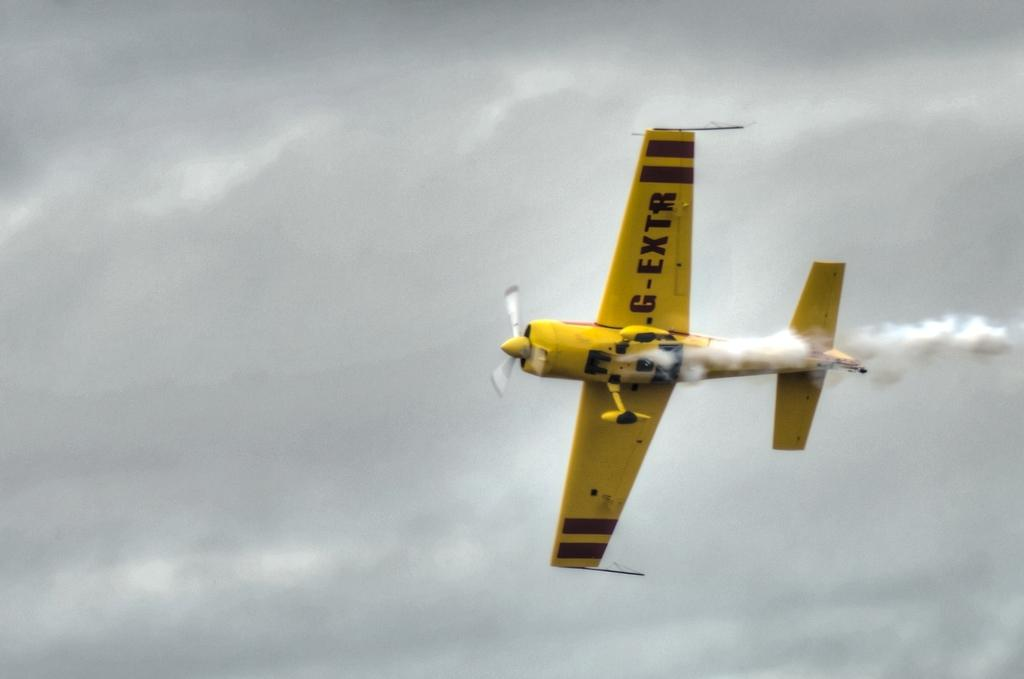<image>
Write a terse but informative summary of the picture. a yellow prop plane in the air with G-Extr on its wing 